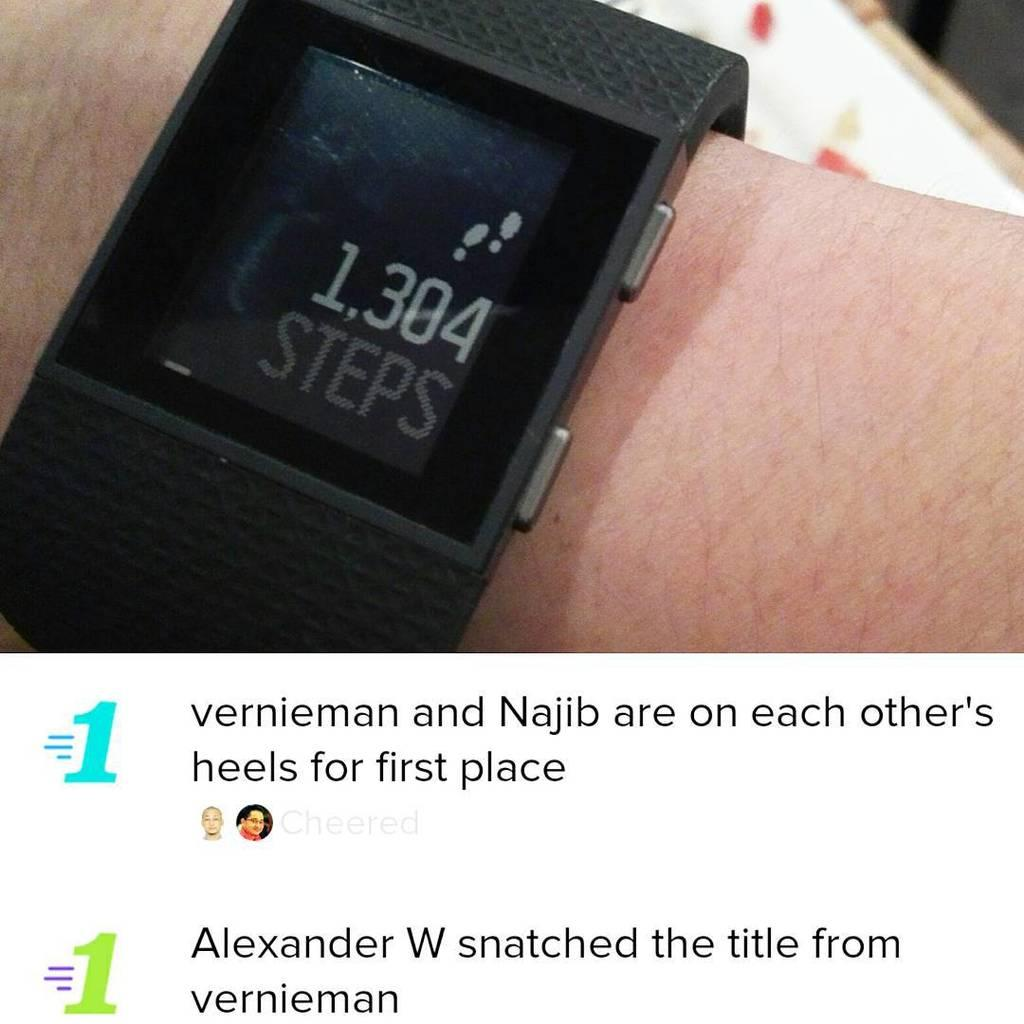<image>
Summarize the visual content of the image. a smart phone reads 1,304 steps with two lines of text under it 